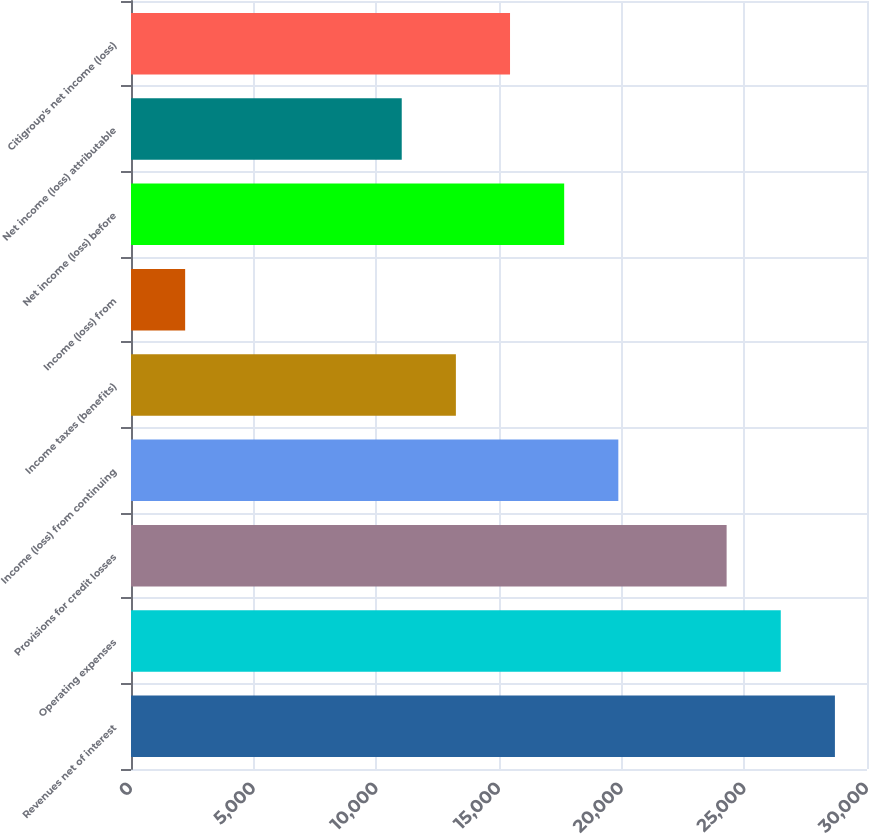Convert chart to OTSL. <chart><loc_0><loc_0><loc_500><loc_500><bar_chart><fcel>Revenues net of interest<fcel>Operating expenses<fcel>Provisions for credit losses<fcel>Income (loss) from continuing<fcel>Income taxes (benefits)<fcel>Income (loss) from<fcel>Net income (loss) before<fcel>Net income (loss) attributable<fcel>Citigroup's net income (loss)<nl><fcel>28692.3<fcel>26485.2<fcel>24278.1<fcel>19863.9<fcel>13242.6<fcel>2207.18<fcel>17656.8<fcel>11035.5<fcel>15449.7<nl></chart> 